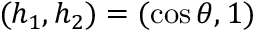Convert formula to latex. <formula><loc_0><loc_0><loc_500><loc_500>( h _ { 1 } , h _ { 2 } ) = ( \cos \theta , 1 )</formula> 